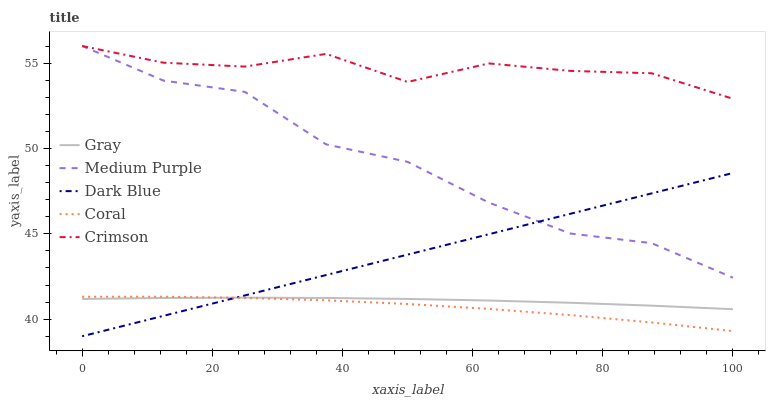Does Coral have the minimum area under the curve?
Answer yes or no. Yes. Does Crimson have the maximum area under the curve?
Answer yes or no. Yes. Does Gray have the minimum area under the curve?
Answer yes or no. No. Does Gray have the maximum area under the curve?
Answer yes or no. No. Is Dark Blue the smoothest?
Answer yes or no. Yes. Is Medium Purple the roughest?
Answer yes or no. Yes. Is Gray the smoothest?
Answer yes or no. No. Is Gray the roughest?
Answer yes or no. No. Does Gray have the lowest value?
Answer yes or no. No. Does Coral have the highest value?
Answer yes or no. No. Is Gray less than Medium Purple?
Answer yes or no. Yes. Is Crimson greater than Gray?
Answer yes or no. Yes. Does Gray intersect Medium Purple?
Answer yes or no. No. 